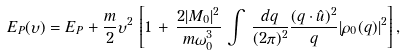<formula> <loc_0><loc_0><loc_500><loc_500>E _ { P } ( \upsilon ) = E _ { P } + \frac { m } { 2 } \upsilon ^ { 2 } \, \left [ 1 \, + \, \frac { 2 | M _ { 0 } | ^ { 2 } } { m \omega _ { 0 } ^ { 3 } } \, \int \, \frac { d { q } } { ( 2 \pi ) ^ { 2 } } \frac { ( { q } \cdot \hat { u } ) ^ { 2 } } { q } | \rho _ { 0 } ( { q } ) | ^ { 2 } \right ] ,</formula> 